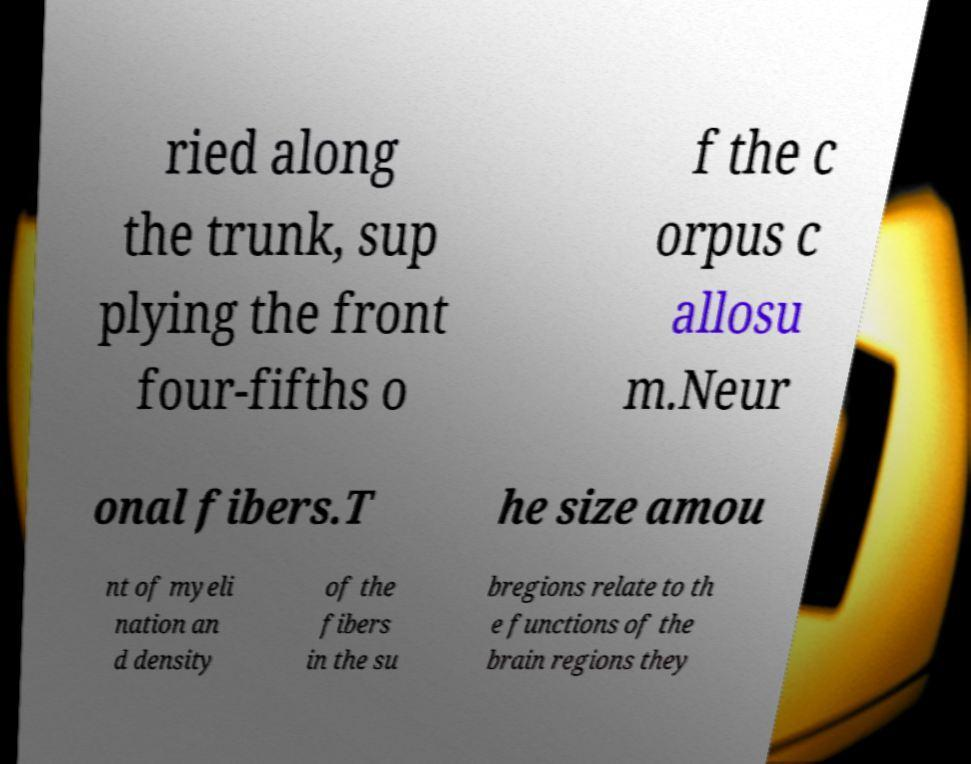What messages or text are displayed in this image? I need them in a readable, typed format. ried along the trunk, sup plying the front four-fifths o f the c orpus c allosu m.Neur onal fibers.T he size amou nt of myeli nation an d density of the fibers in the su bregions relate to th e functions of the brain regions they 